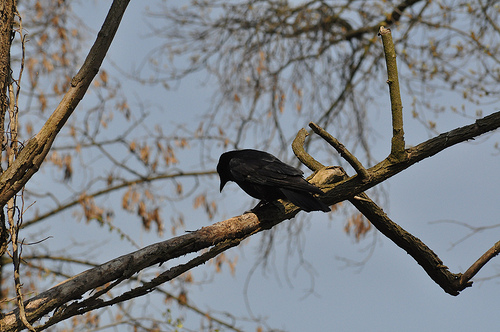<image>
Is there a crow above the tree branch? Yes. The crow is positioned above the tree branch in the vertical space, higher up in the scene. 